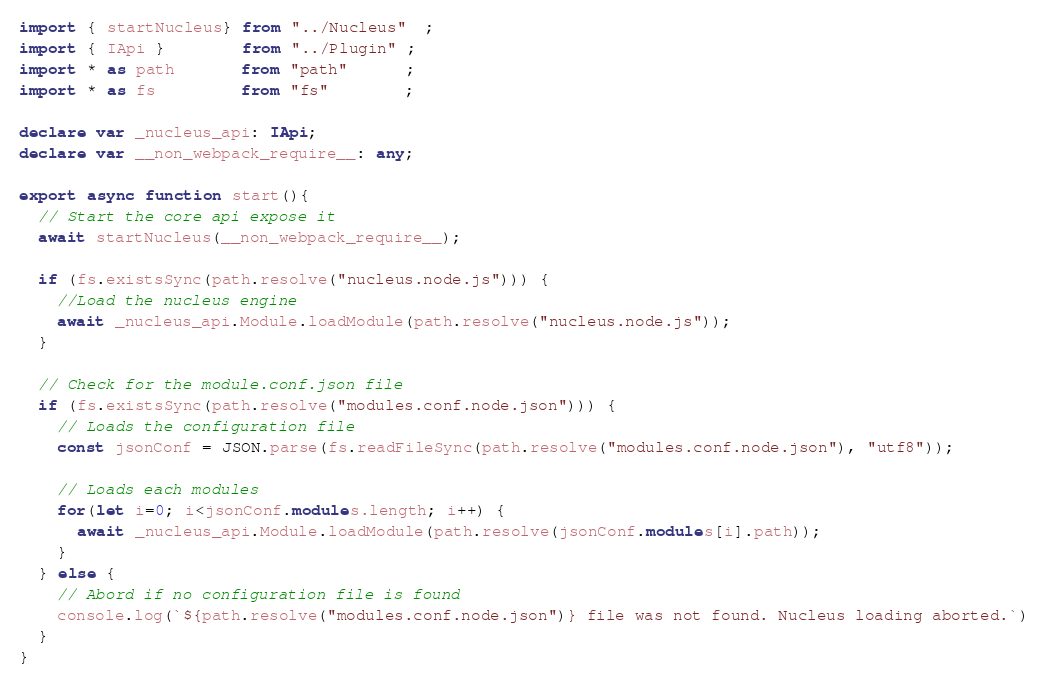Convert code to text. <code><loc_0><loc_0><loc_500><loc_500><_TypeScript_>import { startNucleus} from "../Nucleus"  ;
import { IApi }        from "../Plugin" ;
import * as path       from "path"      ;
import * as fs         from "fs"        ;

declare var _nucleus_api: IApi;
declare var __non_webpack_require__: any;

export async function start(){
  // Start the core api expose it
  await startNucleus(__non_webpack_require__);

  if (fs.existsSync(path.resolve("nucleus.node.js"))) {
    //Load the nucleus engine
    await _nucleus_api.Module.loadModule(path.resolve("nucleus.node.js"));
  }
  
  // Check for the module.conf.json file
  if (fs.existsSync(path.resolve("modules.conf.node.json"))) {
    // Loads the configuration file
    const jsonConf = JSON.parse(fs.readFileSync(path.resolve("modules.conf.node.json"), "utf8"));
    
    // Loads each modules
    for(let i=0; i<jsonConf.modules.length; i++) {
      await _nucleus_api.Module.loadModule(path.resolve(jsonConf.modules[i].path));
    }
  } else {
    // Abord if no configuration file is found
    console.log(`${path.resolve("modules.conf.node.json")} file was not found. Nucleus loading aborted.`)
  }
}</code> 